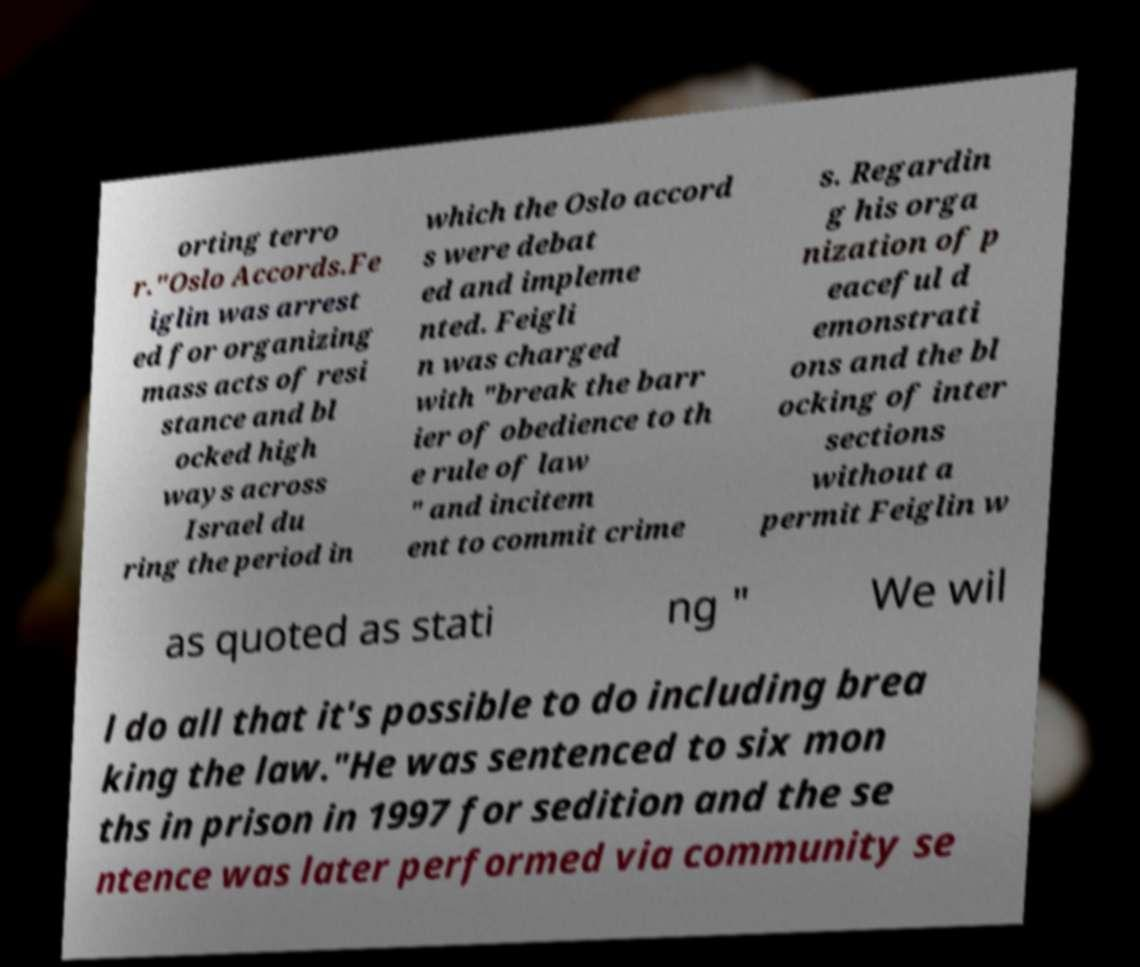Could you extract and type out the text from this image? orting terro r."Oslo Accords.Fe iglin was arrest ed for organizing mass acts of resi stance and bl ocked high ways across Israel du ring the period in which the Oslo accord s were debat ed and impleme nted. Feigli n was charged with "break the barr ier of obedience to th e rule of law " and incitem ent to commit crime s. Regardin g his orga nization of p eaceful d emonstrati ons and the bl ocking of inter sections without a permit Feiglin w as quoted as stati ng " We wil l do all that it's possible to do including brea king the law."He was sentenced to six mon ths in prison in 1997 for sedition and the se ntence was later performed via community se 